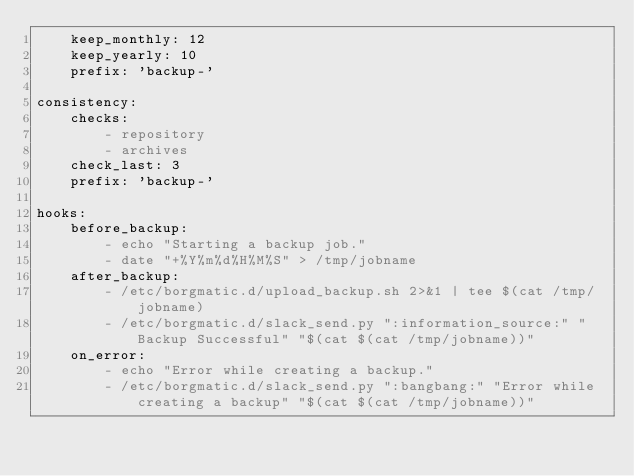Convert code to text. <code><loc_0><loc_0><loc_500><loc_500><_YAML_>    keep_monthly: 12
    keep_yearly: 10
    prefix: 'backup-'

consistency:
    checks:
        - repository
        - archives
    check_last: 3
    prefix: 'backup-'

hooks:
    before_backup:
        - echo "Starting a backup job."
        - date "+%Y%m%d%H%M%S" > /tmp/jobname
    after_backup:
        - /etc/borgmatic.d/upload_backup.sh 2>&1 | tee $(cat /tmp/jobname)
        - /etc/borgmatic.d/slack_send.py ":information_source:" "Backup Successful" "$(cat $(cat /tmp/jobname))"
    on_error:
        - echo "Error while creating a backup."
        - /etc/borgmatic.d/slack_send.py ":bangbang:" "Error while creating a backup" "$(cat $(cat /tmp/jobname))"
</code> 